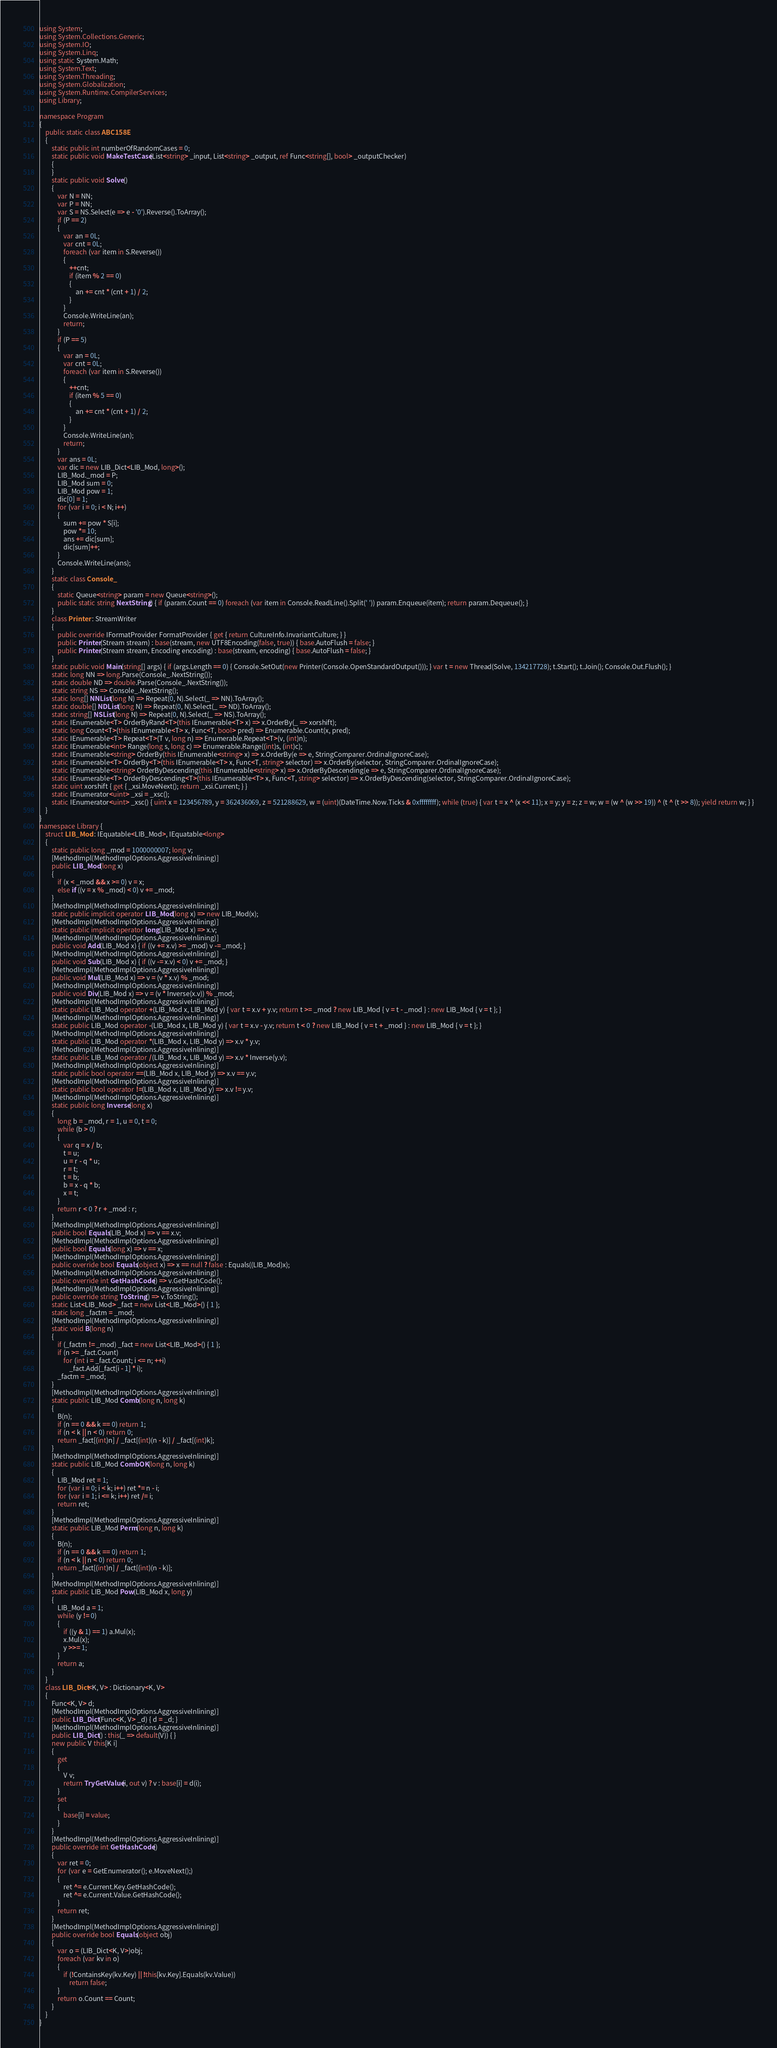Convert code to text. <code><loc_0><loc_0><loc_500><loc_500><_C#_>using System;
using System.Collections.Generic;
using System.IO;
using System.Linq;
using static System.Math;
using System.Text;
using System.Threading;
using System.Globalization;
using System.Runtime.CompilerServices;
using Library;

namespace Program
{
    public static class ABC158E
    {
        static public int numberOfRandomCases = 0;
        static public void MakeTestCase(List<string> _input, List<string> _output, ref Func<string[], bool> _outputChecker)
        {
        }
        static public void Solve()
        {
            var N = NN;
            var P = NN;
            var S = NS.Select(e => e - '0').Reverse().ToArray();
            if (P == 2)
            {
                var an = 0L;
                var cnt = 0L;
                foreach (var item in S.Reverse())
                {
                    ++cnt;
                    if (item % 2 == 0)
                    {
                        an += cnt * (cnt + 1) / 2;
                    }
                }
                Console.WriteLine(an);
                return;
            }
            if (P == 5)
            {
                var an = 0L;
                var cnt = 0L;
                foreach (var item in S.Reverse())
                {
                    ++cnt;
                    if (item % 5 == 0)
                    {
                        an += cnt * (cnt + 1) / 2;
                    }
                }
                Console.WriteLine(an);
                return;
            }
            var ans = 0L;
            var dic = new LIB_Dict<LIB_Mod, long>();
            LIB_Mod._mod = P;
            LIB_Mod sum = 0;
            LIB_Mod pow = 1;
            dic[0] = 1;
            for (var i = 0; i < N; i++)
            {
                sum += pow * S[i];
                pow *= 10;
                ans += dic[sum];
                dic[sum]++;
            }
            Console.WriteLine(ans);
        }
        static class Console_
        {
            static Queue<string> param = new Queue<string>();
            public static string NextString() { if (param.Count == 0) foreach (var item in Console.ReadLine().Split(' ')) param.Enqueue(item); return param.Dequeue(); }
        }
        class Printer : StreamWriter
        {
            public override IFormatProvider FormatProvider { get { return CultureInfo.InvariantCulture; } }
            public Printer(Stream stream) : base(stream, new UTF8Encoding(false, true)) { base.AutoFlush = false; }
            public Printer(Stream stream, Encoding encoding) : base(stream, encoding) { base.AutoFlush = false; }
        }
        static public void Main(string[] args) { if (args.Length == 0) { Console.SetOut(new Printer(Console.OpenStandardOutput())); } var t = new Thread(Solve, 134217728); t.Start(); t.Join(); Console.Out.Flush(); }
        static long NN => long.Parse(Console_.NextString());
        static double ND => double.Parse(Console_.NextString());
        static string NS => Console_.NextString();
        static long[] NNList(long N) => Repeat(0, N).Select(_ => NN).ToArray();
        static double[] NDList(long N) => Repeat(0, N).Select(_ => ND).ToArray();
        static string[] NSList(long N) => Repeat(0, N).Select(_ => NS).ToArray();
        static IEnumerable<T> OrderByRand<T>(this IEnumerable<T> x) => x.OrderBy(_ => xorshift);
        static long Count<T>(this IEnumerable<T> x, Func<T, bool> pred) => Enumerable.Count(x, pred);
        static IEnumerable<T> Repeat<T>(T v, long n) => Enumerable.Repeat<T>(v, (int)n);
        static IEnumerable<int> Range(long s, long c) => Enumerable.Range((int)s, (int)c);
        static IEnumerable<string> OrderBy(this IEnumerable<string> x) => x.OrderBy(e => e, StringComparer.OrdinalIgnoreCase);
        static IEnumerable<T> OrderBy<T>(this IEnumerable<T> x, Func<T, string> selector) => x.OrderBy(selector, StringComparer.OrdinalIgnoreCase);
        static IEnumerable<string> OrderByDescending(this IEnumerable<string> x) => x.OrderByDescending(e => e, StringComparer.OrdinalIgnoreCase);
        static IEnumerable<T> OrderByDescending<T>(this IEnumerable<T> x, Func<T, string> selector) => x.OrderByDescending(selector, StringComparer.OrdinalIgnoreCase);
        static uint xorshift { get { _xsi.MoveNext(); return _xsi.Current; } }
        static IEnumerator<uint> _xsi = _xsc();
        static IEnumerator<uint> _xsc() { uint x = 123456789, y = 362436069, z = 521288629, w = (uint)(DateTime.Now.Ticks & 0xffffffff); while (true) { var t = x ^ (x << 11); x = y; y = z; z = w; w = (w ^ (w >> 19)) ^ (t ^ (t >> 8)); yield return w; } }
    }
}
namespace Library {
    struct LIB_Mod : IEquatable<LIB_Mod>, IEquatable<long>
    {
        static public long _mod = 1000000007; long v;
        [MethodImpl(MethodImplOptions.AggressiveInlining)]
        public LIB_Mod(long x)
        {
            if (x < _mod && x >= 0) v = x;
            else if ((v = x % _mod) < 0) v += _mod;
        }
        [MethodImpl(MethodImplOptions.AggressiveInlining)]
        static public implicit operator LIB_Mod(long x) => new LIB_Mod(x);
        [MethodImpl(MethodImplOptions.AggressiveInlining)]
        static public implicit operator long(LIB_Mod x) => x.v;
        [MethodImpl(MethodImplOptions.AggressiveInlining)]
        public void Add(LIB_Mod x) { if ((v += x.v) >= _mod) v -= _mod; }
        [MethodImpl(MethodImplOptions.AggressiveInlining)]
        public void Sub(LIB_Mod x) { if ((v -= x.v) < 0) v += _mod; }
        [MethodImpl(MethodImplOptions.AggressiveInlining)]
        public void Mul(LIB_Mod x) => v = (v * x.v) % _mod;
        [MethodImpl(MethodImplOptions.AggressiveInlining)]
        public void Div(LIB_Mod x) => v = (v * Inverse(x.v)) % _mod;
        [MethodImpl(MethodImplOptions.AggressiveInlining)]
        static public LIB_Mod operator +(LIB_Mod x, LIB_Mod y) { var t = x.v + y.v; return t >= _mod ? new LIB_Mod { v = t - _mod } : new LIB_Mod { v = t }; }
        [MethodImpl(MethodImplOptions.AggressiveInlining)]
        static public LIB_Mod operator -(LIB_Mod x, LIB_Mod y) { var t = x.v - y.v; return t < 0 ? new LIB_Mod { v = t + _mod } : new LIB_Mod { v = t }; }
        [MethodImpl(MethodImplOptions.AggressiveInlining)]
        static public LIB_Mod operator *(LIB_Mod x, LIB_Mod y) => x.v * y.v;
        [MethodImpl(MethodImplOptions.AggressiveInlining)]
        static public LIB_Mod operator /(LIB_Mod x, LIB_Mod y) => x.v * Inverse(y.v);
        [MethodImpl(MethodImplOptions.AggressiveInlining)]
        static public bool operator ==(LIB_Mod x, LIB_Mod y) => x.v == y.v;
        [MethodImpl(MethodImplOptions.AggressiveInlining)]
        static public bool operator !=(LIB_Mod x, LIB_Mod y) => x.v != y.v;
        [MethodImpl(MethodImplOptions.AggressiveInlining)]
        static public long Inverse(long x)
        {
            long b = _mod, r = 1, u = 0, t = 0;
            while (b > 0)
            {
                var q = x / b;
                t = u;
                u = r - q * u;
                r = t;
                t = b;
                b = x - q * b;
                x = t;
            }
            return r < 0 ? r + _mod : r;
        }
        [MethodImpl(MethodImplOptions.AggressiveInlining)]
        public bool Equals(LIB_Mod x) => v == x.v;
        [MethodImpl(MethodImplOptions.AggressiveInlining)]
        public bool Equals(long x) => v == x;
        [MethodImpl(MethodImplOptions.AggressiveInlining)]
        public override bool Equals(object x) => x == null ? false : Equals((LIB_Mod)x);
        [MethodImpl(MethodImplOptions.AggressiveInlining)]
        public override int GetHashCode() => v.GetHashCode();
        [MethodImpl(MethodImplOptions.AggressiveInlining)]
        public override string ToString() => v.ToString();
        static List<LIB_Mod> _fact = new List<LIB_Mod>() { 1 };
        static long _factm = _mod;
        [MethodImpl(MethodImplOptions.AggressiveInlining)]
        static void B(long n)
        {
            if (_factm != _mod) _fact = new List<LIB_Mod>() { 1 };
            if (n >= _fact.Count)
                for (int i = _fact.Count; i <= n; ++i)
                    _fact.Add(_fact[i - 1] * i);
            _factm = _mod;
        }
        [MethodImpl(MethodImplOptions.AggressiveInlining)]
        static public LIB_Mod Comb(long n, long k)
        {
            B(n);
            if (n == 0 && k == 0) return 1;
            if (n < k || n < 0) return 0;
            return _fact[(int)n] / _fact[(int)(n - k)] / _fact[(int)k];
        }
        [MethodImpl(MethodImplOptions.AggressiveInlining)]
        static public LIB_Mod CombOK(long n, long k)
        {
            LIB_Mod ret = 1;
            for (var i = 0; i < k; i++) ret *= n - i;
            for (var i = 1; i <= k; i++) ret /= i;
            return ret;
        }
        [MethodImpl(MethodImplOptions.AggressiveInlining)]
        static public LIB_Mod Perm(long n, long k)
        {
            B(n);
            if (n == 0 && k == 0) return 1;
            if (n < k || n < 0) return 0;
            return _fact[(int)n] / _fact[(int)(n - k)];
        }
        [MethodImpl(MethodImplOptions.AggressiveInlining)]
        static public LIB_Mod Pow(LIB_Mod x, long y)
        {
            LIB_Mod a = 1;
            while (y != 0)
            {
                if ((y & 1) == 1) a.Mul(x);
                x.Mul(x);
                y >>= 1;
            }
            return a;
        }
    }
    class LIB_Dict<K, V> : Dictionary<K, V>
    {
        Func<K, V> d;
        [MethodImpl(MethodImplOptions.AggressiveInlining)]
        public LIB_Dict(Func<K, V> _d) { d = _d; }
        [MethodImpl(MethodImplOptions.AggressiveInlining)]
        public LIB_Dict() : this(_ => default(V)) { }
        new public V this[K i]
        {
            get
            {
                V v;
                return TryGetValue(i, out v) ? v : base[i] = d(i);
            }
            set
            {
                base[i] = value;
            }
        }
        [MethodImpl(MethodImplOptions.AggressiveInlining)]
        public override int GetHashCode()
        {
            var ret = 0;
            for (var e = GetEnumerator(); e.MoveNext();)
            {
                ret ^= e.Current.Key.GetHashCode();
                ret ^= e.Current.Value.GetHashCode();
            }
            return ret;
        }
        [MethodImpl(MethodImplOptions.AggressiveInlining)]
        public override bool Equals(object obj)
        {
            var o = (LIB_Dict<K, V>)obj;
            foreach (var kv in o)
            {
                if (!ContainsKey(kv.Key) || !this[kv.Key].Equals(kv.Value))
                    return false;
            }
            return o.Count == Count;
        }
    }
}
</code> 